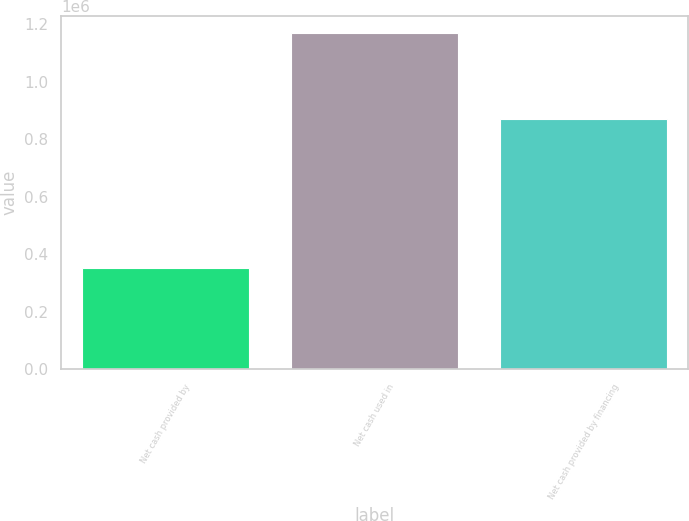Convert chart to OTSL. <chart><loc_0><loc_0><loc_500><loc_500><bar_chart><fcel>Net cash provided by<fcel>Net cash used in<fcel>Net cash provided by financing<nl><fcel>353743<fcel>1.17039e+06<fcel>868442<nl></chart> 